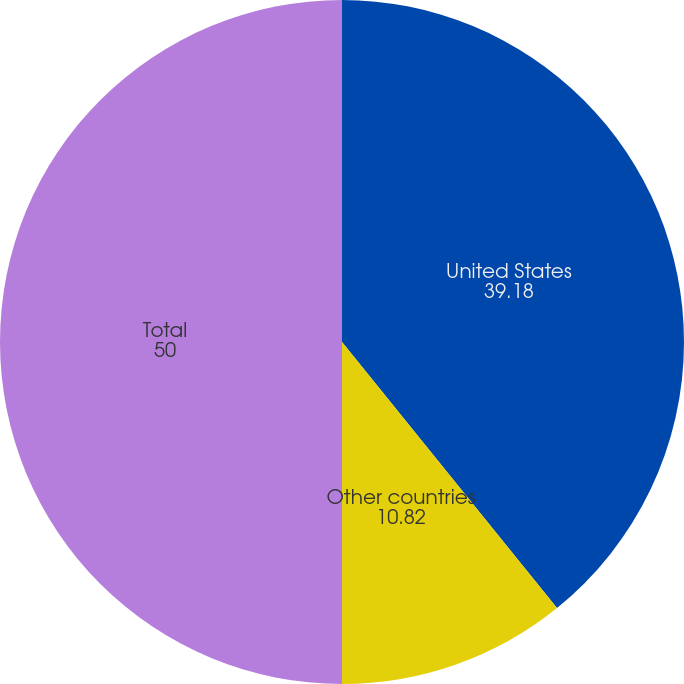Convert chart. <chart><loc_0><loc_0><loc_500><loc_500><pie_chart><fcel>United States<fcel>Other countries<fcel>Total<nl><fcel>39.18%<fcel>10.82%<fcel>50.0%<nl></chart> 